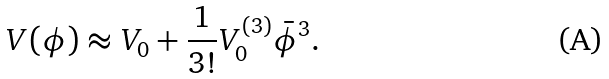<formula> <loc_0><loc_0><loc_500><loc_500>V ( \phi ) \approx V _ { 0 } + \frac { 1 } { 3 ! } V ^ { ( 3 ) } _ { 0 } \bar { \phi } ^ { 3 } .</formula> 